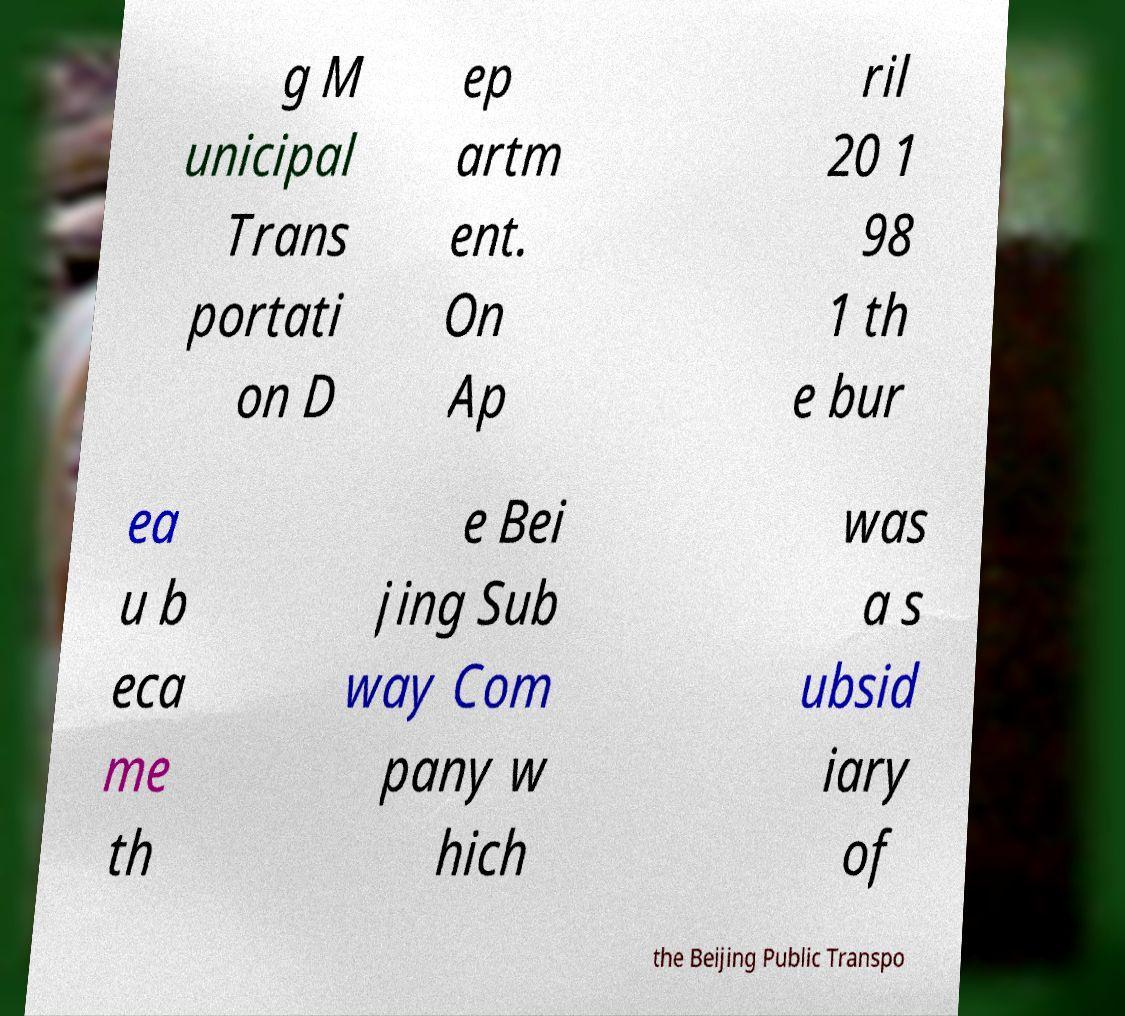Can you accurately transcribe the text from the provided image for me? g M unicipal Trans portati on D ep artm ent. On Ap ril 20 1 98 1 th e bur ea u b eca me th e Bei jing Sub way Com pany w hich was a s ubsid iary of the Beijing Public Transpo 